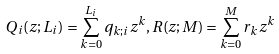<formula> <loc_0><loc_0><loc_500><loc_500>Q _ { i } ( z ; L _ { i } ) = \sum _ { k = 0 } ^ { L _ { i } } q _ { k ; i } z ^ { k } , R ( z ; M ) = \sum _ { k = 0 } ^ { M } r _ { k } z ^ { k }</formula> 